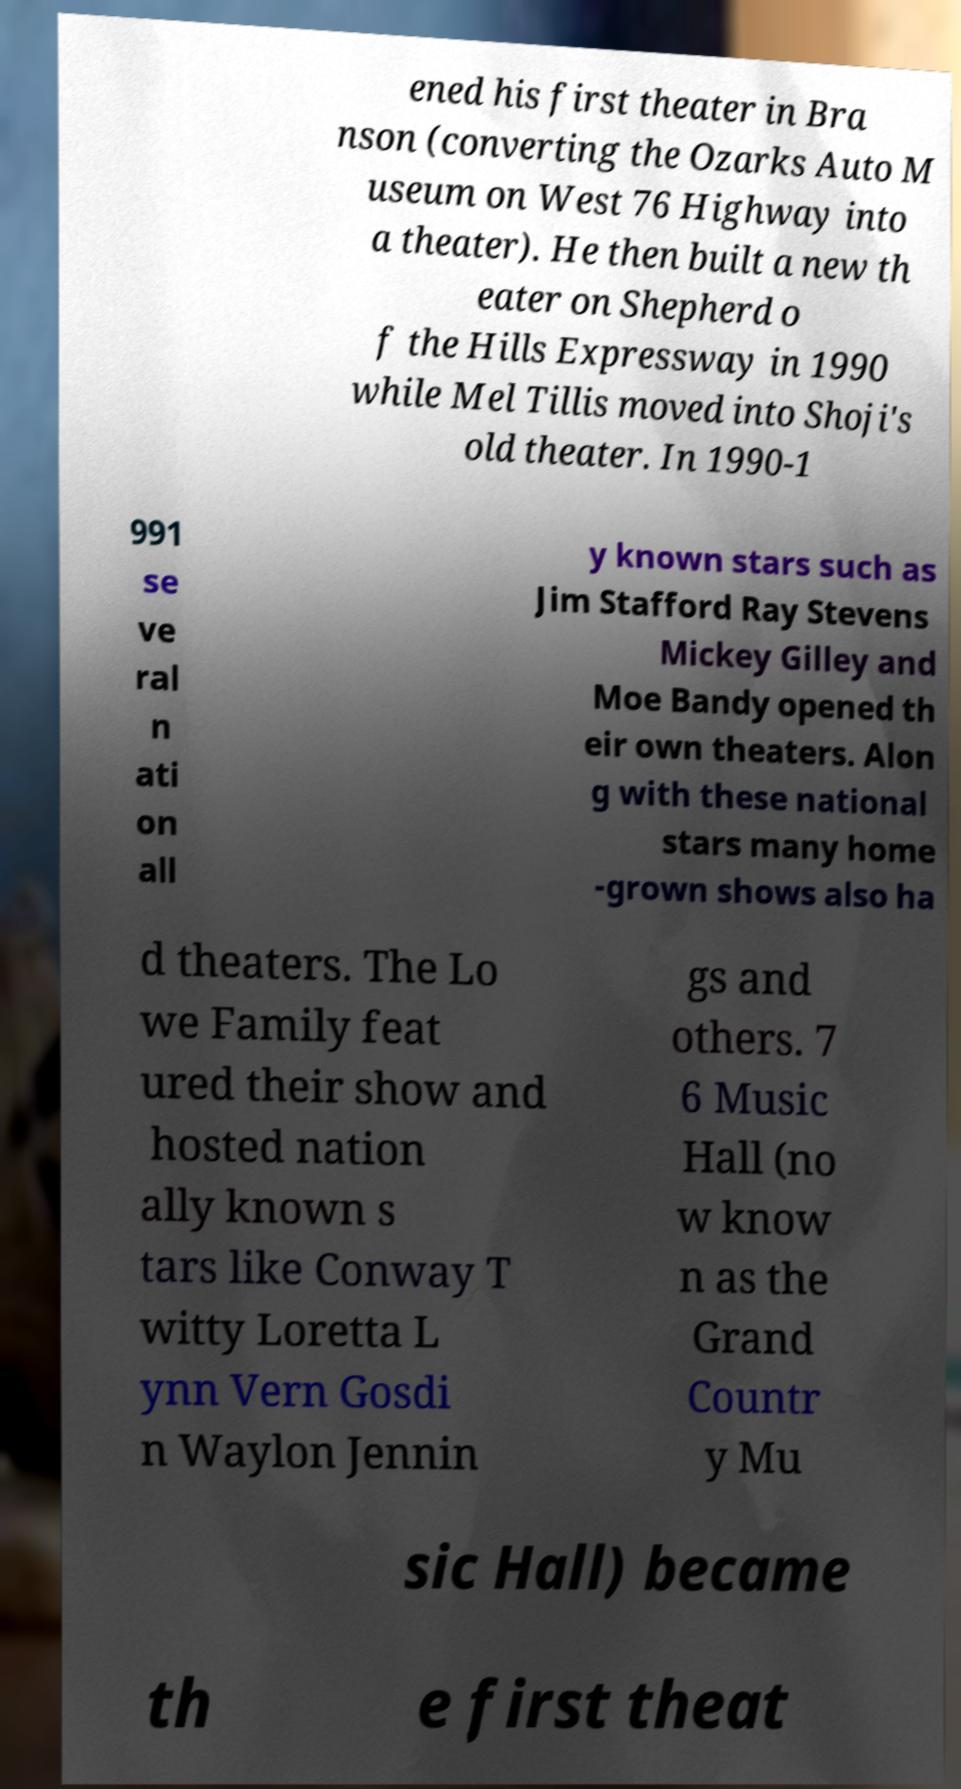Could you extract and type out the text from this image? ened his first theater in Bra nson (converting the Ozarks Auto M useum on West 76 Highway into a theater). He then built a new th eater on Shepherd o f the Hills Expressway in 1990 while Mel Tillis moved into Shoji's old theater. In 1990-1 991 se ve ral n ati on all y known stars such as Jim Stafford Ray Stevens Mickey Gilley and Moe Bandy opened th eir own theaters. Alon g with these national stars many home -grown shows also ha d theaters. The Lo we Family feat ured their show and hosted nation ally known s tars like Conway T witty Loretta L ynn Vern Gosdi n Waylon Jennin gs and others. 7 6 Music Hall (no w know n as the Grand Countr y Mu sic Hall) became th e first theat 